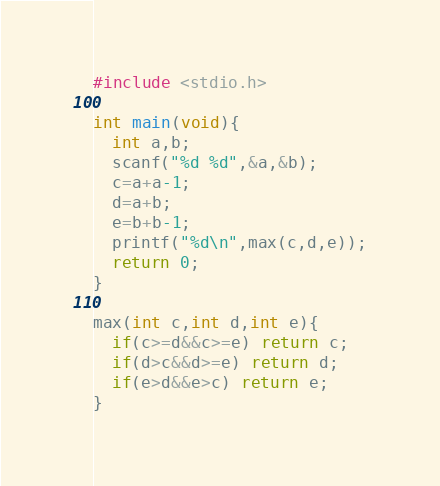Convert code to text. <code><loc_0><loc_0><loc_500><loc_500><_C_>#include <stdio.h>

int main(void){
  int a,b;
  scanf("%d %d",&a,&b);
  c=a+a-1;
  d=a+b;
  e=b+b-1;
  printf("%d\n",max(c,d,e));
  return 0;
}

max(int c,int d,int e){
  if(c>=d&&c>=e) return c;
  if(d>c&&d>=e) return d;
  if(e>d&&e>c) return e;
}</code> 